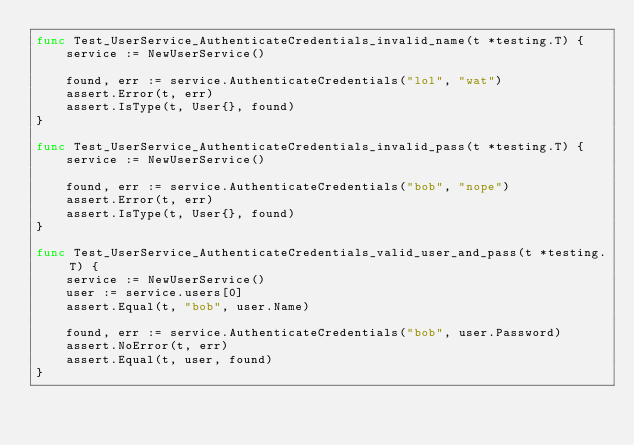<code> <loc_0><loc_0><loc_500><loc_500><_Go_>func Test_UserService_AuthenticateCredentials_invalid_name(t *testing.T) {
    service := NewUserService()

    found, err := service.AuthenticateCredentials("lol", "wat")
    assert.Error(t, err)
    assert.IsType(t, User{}, found)
}

func Test_UserService_AuthenticateCredentials_invalid_pass(t *testing.T) {
    service := NewUserService()

    found, err := service.AuthenticateCredentials("bob", "nope")
    assert.Error(t, err)
    assert.IsType(t, User{}, found)
}

func Test_UserService_AuthenticateCredentials_valid_user_and_pass(t *testing.T) {
    service := NewUserService()
    user := service.users[0]
    assert.Equal(t, "bob", user.Name)

    found, err := service.AuthenticateCredentials("bob", user.Password)
    assert.NoError(t, err)
    assert.Equal(t, user, found)
}
</code> 